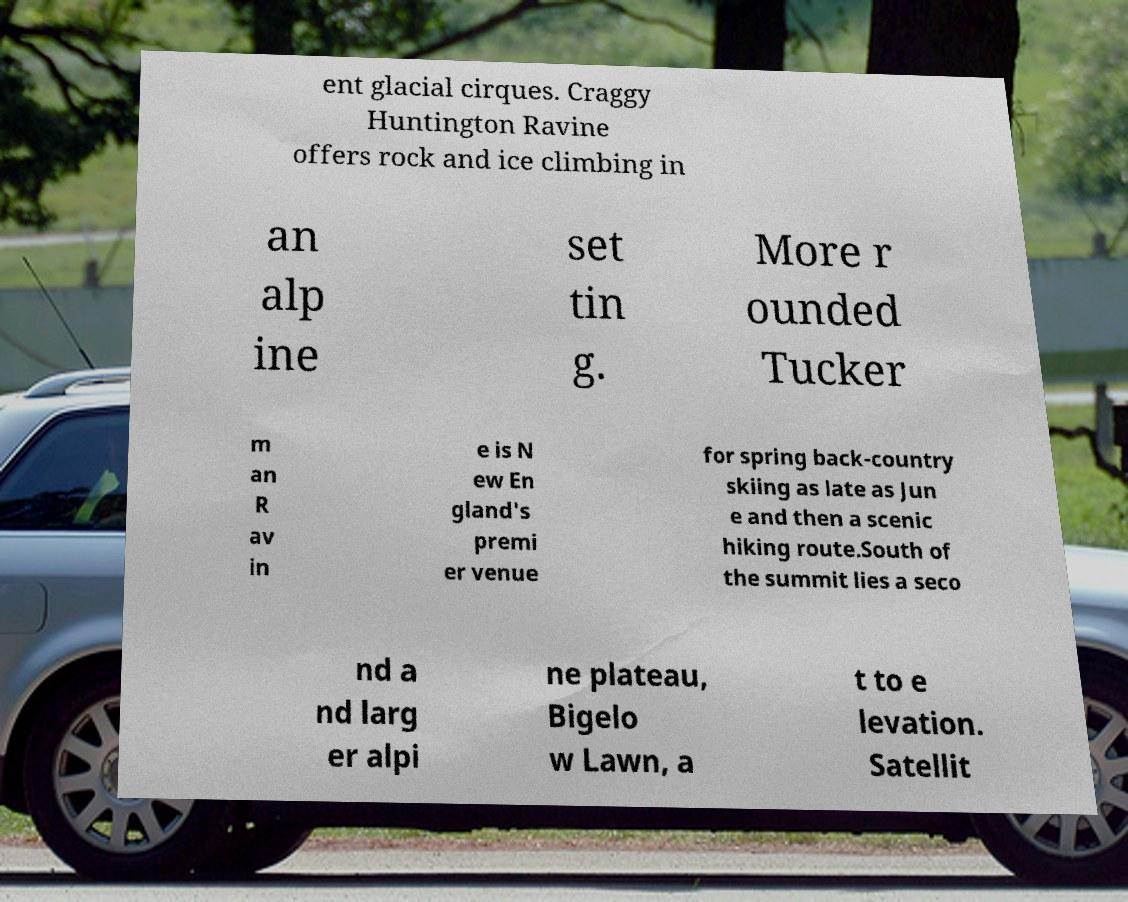Please read and relay the text visible in this image. What does it say? ent glacial cirques. Craggy Huntington Ravine offers rock and ice climbing in an alp ine set tin g. More r ounded Tucker m an R av in e is N ew En gland's premi er venue for spring back-country skiing as late as Jun e and then a scenic hiking route.South of the summit lies a seco nd a nd larg er alpi ne plateau, Bigelo w Lawn, a t to e levation. Satellit 